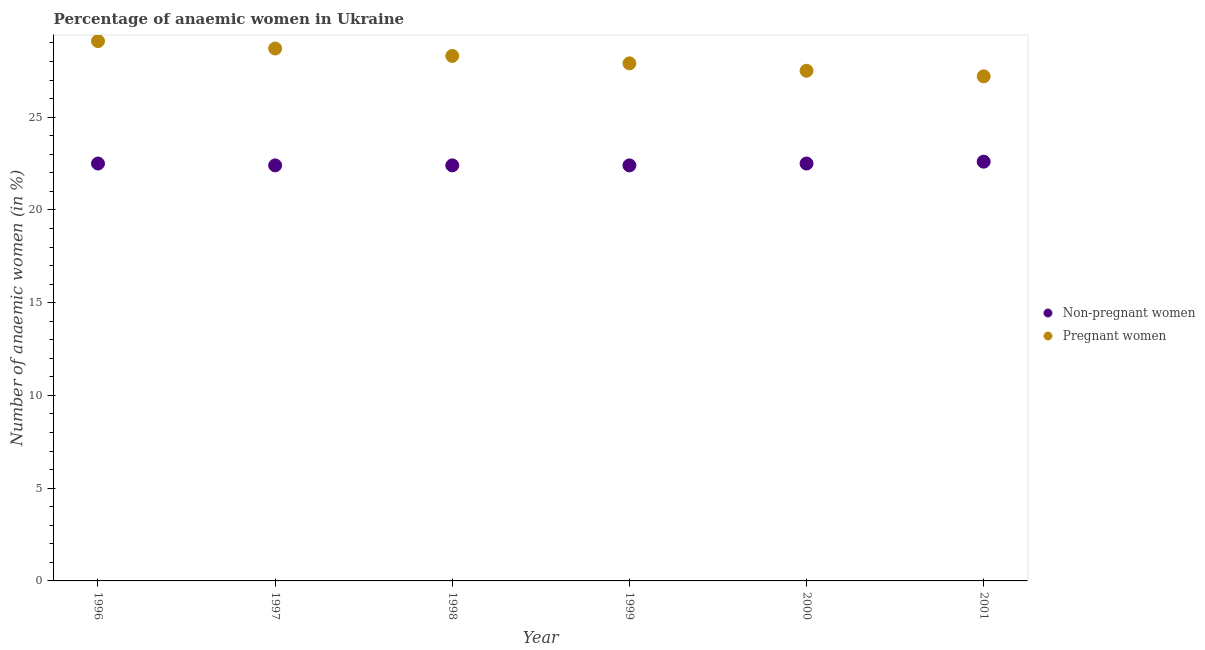How many different coloured dotlines are there?
Keep it short and to the point. 2. What is the percentage of non-pregnant anaemic women in 1996?
Your answer should be very brief. 22.5. Across all years, what is the maximum percentage of pregnant anaemic women?
Provide a succinct answer. 29.1. Across all years, what is the minimum percentage of non-pregnant anaemic women?
Give a very brief answer. 22.4. What is the total percentage of non-pregnant anaemic women in the graph?
Provide a succinct answer. 134.8. What is the difference between the percentage of non-pregnant anaemic women in 1996 and that in 1997?
Offer a very short reply. 0.1. What is the difference between the percentage of pregnant anaemic women in 1999 and the percentage of non-pregnant anaemic women in 2000?
Offer a very short reply. 5.4. What is the average percentage of non-pregnant anaemic women per year?
Ensure brevity in your answer.  22.47. In the year 1998, what is the difference between the percentage of non-pregnant anaemic women and percentage of pregnant anaemic women?
Ensure brevity in your answer.  -5.9. What is the ratio of the percentage of pregnant anaemic women in 2000 to that in 2001?
Make the answer very short. 1.01. Is the percentage of pregnant anaemic women in 1999 less than that in 2000?
Provide a short and direct response. No. What is the difference between the highest and the second highest percentage of non-pregnant anaemic women?
Your answer should be very brief. 0.1. What is the difference between the highest and the lowest percentage of pregnant anaemic women?
Your response must be concise. 1.9. How many dotlines are there?
Make the answer very short. 2. What is the difference between two consecutive major ticks on the Y-axis?
Give a very brief answer. 5. Does the graph contain any zero values?
Offer a terse response. No. Where does the legend appear in the graph?
Ensure brevity in your answer.  Center right. What is the title of the graph?
Ensure brevity in your answer.  Percentage of anaemic women in Ukraine. What is the label or title of the Y-axis?
Offer a very short reply. Number of anaemic women (in %). What is the Number of anaemic women (in %) of Pregnant women in 1996?
Provide a short and direct response. 29.1. What is the Number of anaemic women (in %) in Non-pregnant women in 1997?
Ensure brevity in your answer.  22.4. What is the Number of anaemic women (in %) in Pregnant women in 1997?
Provide a succinct answer. 28.7. What is the Number of anaemic women (in %) in Non-pregnant women in 1998?
Your answer should be compact. 22.4. What is the Number of anaemic women (in %) of Pregnant women in 1998?
Your answer should be compact. 28.3. What is the Number of anaemic women (in %) of Non-pregnant women in 1999?
Your answer should be very brief. 22.4. What is the Number of anaemic women (in %) in Pregnant women in 1999?
Your answer should be compact. 27.9. What is the Number of anaemic women (in %) in Pregnant women in 2000?
Offer a very short reply. 27.5. What is the Number of anaemic women (in %) in Non-pregnant women in 2001?
Your response must be concise. 22.6. What is the Number of anaemic women (in %) in Pregnant women in 2001?
Keep it short and to the point. 27.2. Across all years, what is the maximum Number of anaemic women (in %) of Non-pregnant women?
Keep it short and to the point. 22.6. Across all years, what is the maximum Number of anaemic women (in %) of Pregnant women?
Keep it short and to the point. 29.1. Across all years, what is the minimum Number of anaemic women (in %) of Non-pregnant women?
Make the answer very short. 22.4. Across all years, what is the minimum Number of anaemic women (in %) of Pregnant women?
Provide a short and direct response. 27.2. What is the total Number of anaemic women (in %) of Non-pregnant women in the graph?
Keep it short and to the point. 134.8. What is the total Number of anaemic women (in %) in Pregnant women in the graph?
Your answer should be compact. 168.7. What is the difference between the Number of anaemic women (in %) in Non-pregnant women in 1996 and that in 1997?
Keep it short and to the point. 0.1. What is the difference between the Number of anaemic women (in %) in Pregnant women in 1996 and that in 1998?
Make the answer very short. 0.8. What is the difference between the Number of anaemic women (in %) of Pregnant women in 1996 and that in 2000?
Keep it short and to the point. 1.6. What is the difference between the Number of anaemic women (in %) of Non-pregnant women in 1996 and that in 2001?
Your response must be concise. -0.1. What is the difference between the Number of anaemic women (in %) of Non-pregnant women in 1997 and that in 1998?
Offer a very short reply. 0. What is the difference between the Number of anaemic women (in %) in Pregnant women in 1997 and that in 1998?
Your response must be concise. 0.4. What is the difference between the Number of anaemic women (in %) in Pregnant women in 1997 and that in 1999?
Offer a very short reply. 0.8. What is the difference between the Number of anaemic women (in %) in Non-pregnant women in 1997 and that in 2000?
Provide a succinct answer. -0.1. What is the difference between the Number of anaemic women (in %) in Pregnant women in 1997 and that in 2001?
Provide a succinct answer. 1.5. What is the difference between the Number of anaemic women (in %) of Non-pregnant women in 1998 and that in 1999?
Provide a short and direct response. 0. What is the difference between the Number of anaemic women (in %) in Pregnant women in 1998 and that in 1999?
Make the answer very short. 0.4. What is the difference between the Number of anaemic women (in %) in Non-pregnant women in 1998 and that in 2000?
Keep it short and to the point. -0.1. What is the difference between the Number of anaemic women (in %) in Pregnant women in 1998 and that in 2000?
Provide a succinct answer. 0.8. What is the difference between the Number of anaemic women (in %) in Non-pregnant women in 1998 and that in 2001?
Give a very brief answer. -0.2. What is the difference between the Number of anaemic women (in %) of Non-pregnant women in 1999 and that in 2000?
Give a very brief answer. -0.1. What is the difference between the Number of anaemic women (in %) of Non-pregnant women in 1999 and that in 2001?
Give a very brief answer. -0.2. What is the difference between the Number of anaemic women (in %) in Pregnant women in 1999 and that in 2001?
Your answer should be very brief. 0.7. What is the difference between the Number of anaemic women (in %) in Non-pregnant women in 2000 and that in 2001?
Make the answer very short. -0.1. What is the difference between the Number of anaemic women (in %) of Pregnant women in 2000 and that in 2001?
Provide a succinct answer. 0.3. What is the difference between the Number of anaemic women (in %) of Non-pregnant women in 1996 and the Number of anaemic women (in %) of Pregnant women in 1998?
Offer a very short reply. -5.8. What is the difference between the Number of anaemic women (in %) of Non-pregnant women in 1996 and the Number of anaemic women (in %) of Pregnant women in 2000?
Offer a terse response. -5. What is the difference between the Number of anaemic women (in %) in Non-pregnant women in 1997 and the Number of anaemic women (in %) in Pregnant women in 1998?
Make the answer very short. -5.9. What is the difference between the Number of anaemic women (in %) in Non-pregnant women in 1997 and the Number of anaemic women (in %) in Pregnant women in 1999?
Offer a very short reply. -5.5. What is the difference between the Number of anaemic women (in %) of Non-pregnant women in 1997 and the Number of anaemic women (in %) of Pregnant women in 2000?
Your response must be concise. -5.1. What is the difference between the Number of anaemic women (in %) in Non-pregnant women in 1998 and the Number of anaemic women (in %) in Pregnant women in 1999?
Provide a short and direct response. -5.5. What is the difference between the Number of anaemic women (in %) of Non-pregnant women in 1999 and the Number of anaemic women (in %) of Pregnant women in 2001?
Ensure brevity in your answer.  -4.8. What is the difference between the Number of anaemic women (in %) of Non-pregnant women in 2000 and the Number of anaemic women (in %) of Pregnant women in 2001?
Offer a very short reply. -4.7. What is the average Number of anaemic women (in %) in Non-pregnant women per year?
Your response must be concise. 22.47. What is the average Number of anaemic women (in %) of Pregnant women per year?
Keep it short and to the point. 28.12. In the year 1999, what is the difference between the Number of anaemic women (in %) in Non-pregnant women and Number of anaemic women (in %) in Pregnant women?
Your answer should be compact. -5.5. What is the ratio of the Number of anaemic women (in %) in Non-pregnant women in 1996 to that in 1997?
Offer a very short reply. 1. What is the ratio of the Number of anaemic women (in %) in Pregnant women in 1996 to that in 1997?
Offer a very short reply. 1.01. What is the ratio of the Number of anaemic women (in %) in Pregnant women in 1996 to that in 1998?
Your answer should be very brief. 1.03. What is the ratio of the Number of anaemic women (in %) in Pregnant women in 1996 to that in 1999?
Provide a short and direct response. 1.04. What is the ratio of the Number of anaemic women (in %) in Pregnant women in 1996 to that in 2000?
Provide a succinct answer. 1.06. What is the ratio of the Number of anaemic women (in %) in Non-pregnant women in 1996 to that in 2001?
Keep it short and to the point. 1. What is the ratio of the Number of anaemic women (in %) in Pregnant women in 1996 to that in 2001?
Your answer should be very brief. 1.07. What is the ratio of the Number of anaemic women (in %) in Non-pregnant women in 1997 to that in 1998?
Keep it short and to the point. 1. What is the ratio of the Number of anaemic women (in %) of Pregnant women in 1997 to that in 1998?
Offer a very short reply. 1.01. What is the ratio of the Number of anaemic women (in %) of Non-pregnant women in 1997 to that in 1999?
Provide a succinct answer. 1. What is the ratio of the Number of anaemic women (in %) of Pregnant women in 1997 to that in 1999?
Ensure brevity in your answer.  1.03. What is the ratio of the Number of anaemic women (in %) in Non-pregnant women in 1997 to that in 2000?
Your response must be concise. 1. What is the ratio of the Number of anaemic women (in %) in Pregnant women in 1997 to that in 2000?
Offer a very short reply. 1.04. What is the ratio of the Number of anaemic women (in %) in Pregnant women in 1997 to that in 2001?
Your response must be concise. 1.06. What is the ratio of the Number of anaemic women (in %) in Pregnant women in 1998 to that in 1999?
Provide a short and direct response. 1.01. What is the ratio of the Number of anaemic women (in %) in Non-pregnant women in 1998 to that in 2000?
Give a very brief answer. 1. What is the ratio of the Number of anaemic women (in %) of Pregnant women in 1998 to that in 2000?
Your answer should be very brief. 1.03. What is the ratio of the Number of anaemic women (in %) of Non-pregnant women in 1998 to that in 2001?
Give a very brief answer. 0.99. What is the ratio of the Number of anaemic women (in %) of Pregnant women in 1998 to that in 2001?
Your response must be concise. 1.04. What is the ratio of the Number of anaemic women (in %) of Pregnant women in 1999 to that in 2000?
Your answer should be very brief. 1.01. What is the ratio of the Number of anaemic women (in %) of Non-pregnant women in 1999 to that in 2001?
Keep it short and to the point. 0.99. What is the ratio of the Number of anaemic women (in %) in Pregnant women in 1999 to that in 2001?
Keep it short and to the point. 1.03. What is the ratio of the Number of anaemic women (in %) in Non-pregnant women in 2000 to that in 2001?
Your answer should be very brief. 1. What is the difference between the highest and the second highest Number of anaemic women (in %) of Non-pregnant women?
Provide a short and direct response. 0.1. What is the difference between the highest and the lowest Number of anaemic women (in %) of Non-pregnant women?
Make the answer very short. 0.2. What is the difference between the highest and the lowest Number of anaemic women (in %) in Pregnant women?
Make the answer very short. 1.9. 